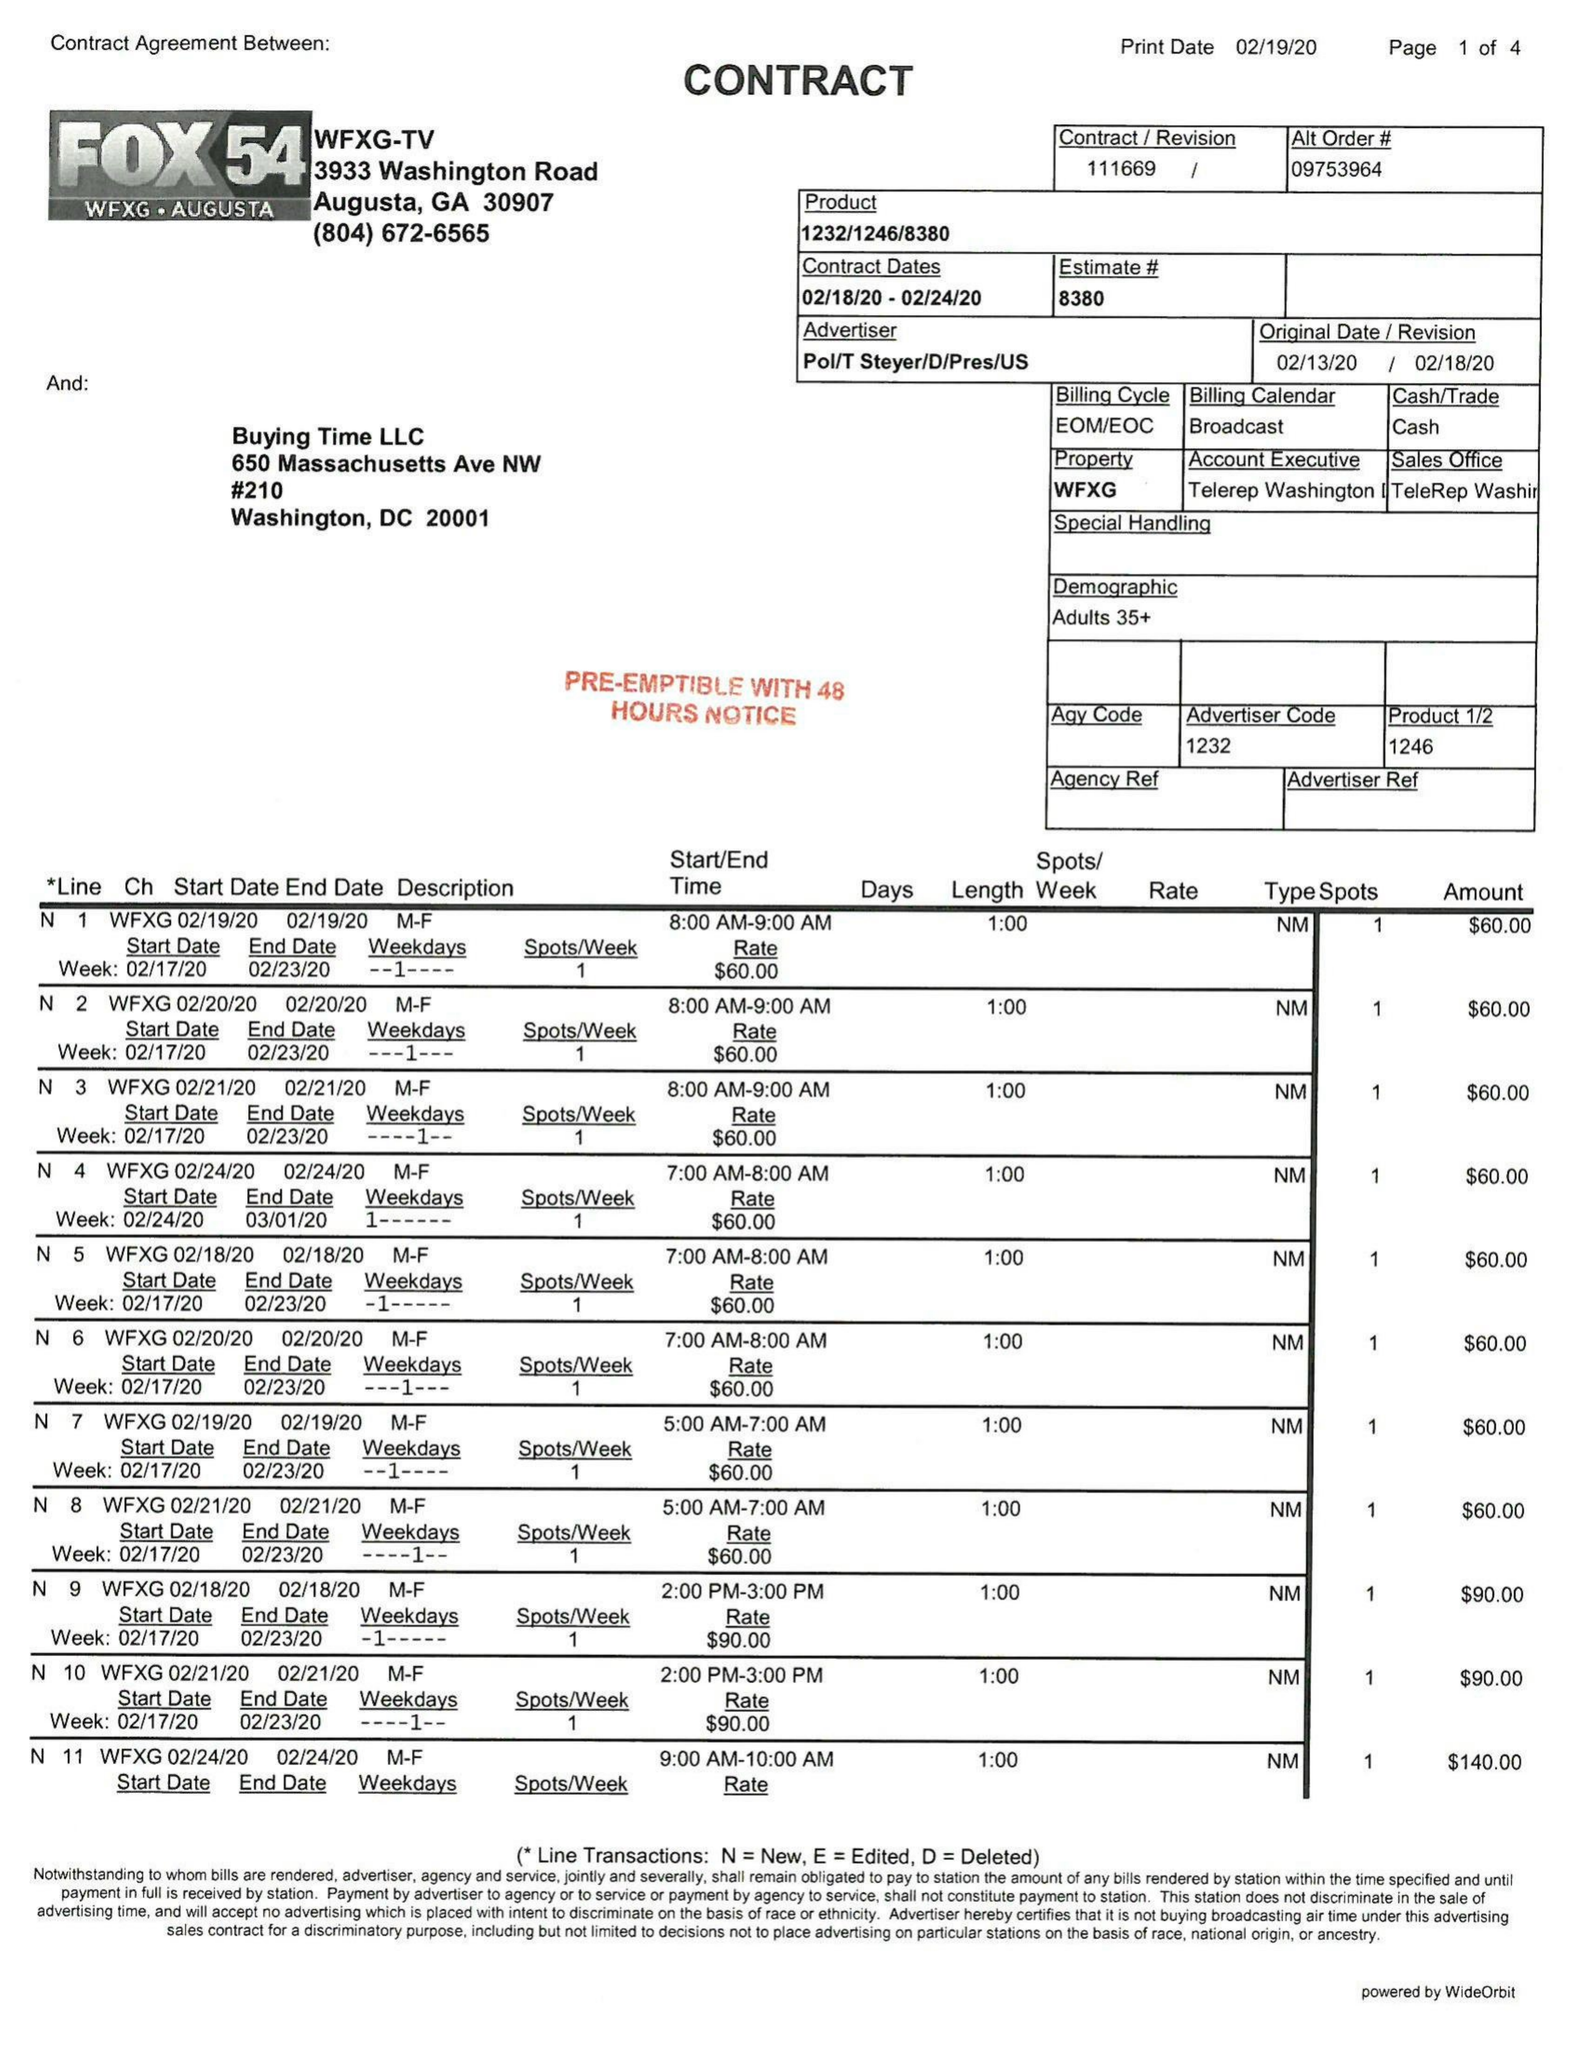What is the value for the flight_from?
Answer the question using a single word or phrase. 02/18/20 